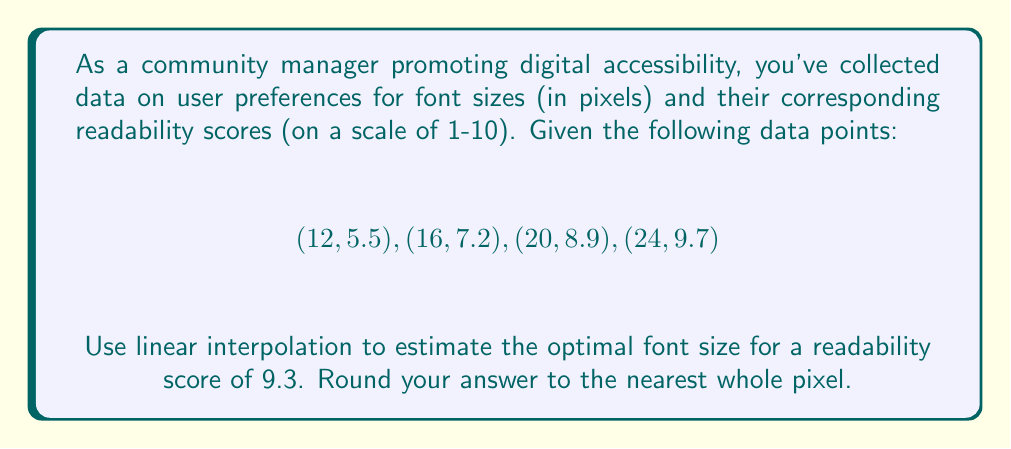Could you help me with this problem? To solve this problem using linear interpolation, we'll follow these steps:

1. Identify the two data points between which the desired readability score (9.3) falls:
   $(20, 8.9)$ and $(24, 9.7)$

2. Use the linear interpolation formula:
   $$y = y_1 + \frac{(x - x_1)(y_2 - y_1)}{(x_2 - x_1)}$$
   where $(x_1, y_1)$ is the lower point and $(x_2, y_2)$ is the upper point.

3. In our case:
   $x_1 = 20$, $y_1 = 8.9$
   $x_2 = 24$, $y_2 = 9.7$
   $y = 9.3$ (desired readability score)
   $x$ is the unknown font size we're solving for

4. Plug these values into the formula:
   $$9.3 = 8.9 + \frac{(x - 20)(9.7 - 8.9)}{(24 - 20)}$$

5. Simplify:
   $$9.3 = 8.9 + \frac{(x - 20)(0.8)}{4}$$
   $$9.3 = 8.9 + 0.2(x - 20)$$

6. Solve for $x$:
   $$0.4 = 0.2(x - 20)$$
   $$2 = x - 20$$
   $$x = 22$$

7. The optimal font size is 22 pixels (already a whole number, so no rounding needed).
Answer: 22 pixels 